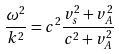Convert formula to latex. <formula><loc_0><loc_0><loc_500><loc_500>\frac { \omega ^ { 2 } } { k ^ { 2 } } = c ^ { 2 } \frac { v _ { s } ^ { 2 } + v _ { A } ^ { 2 } } { c ^ { 2 } + v _ { A } ^ { 2 } }</formula> 